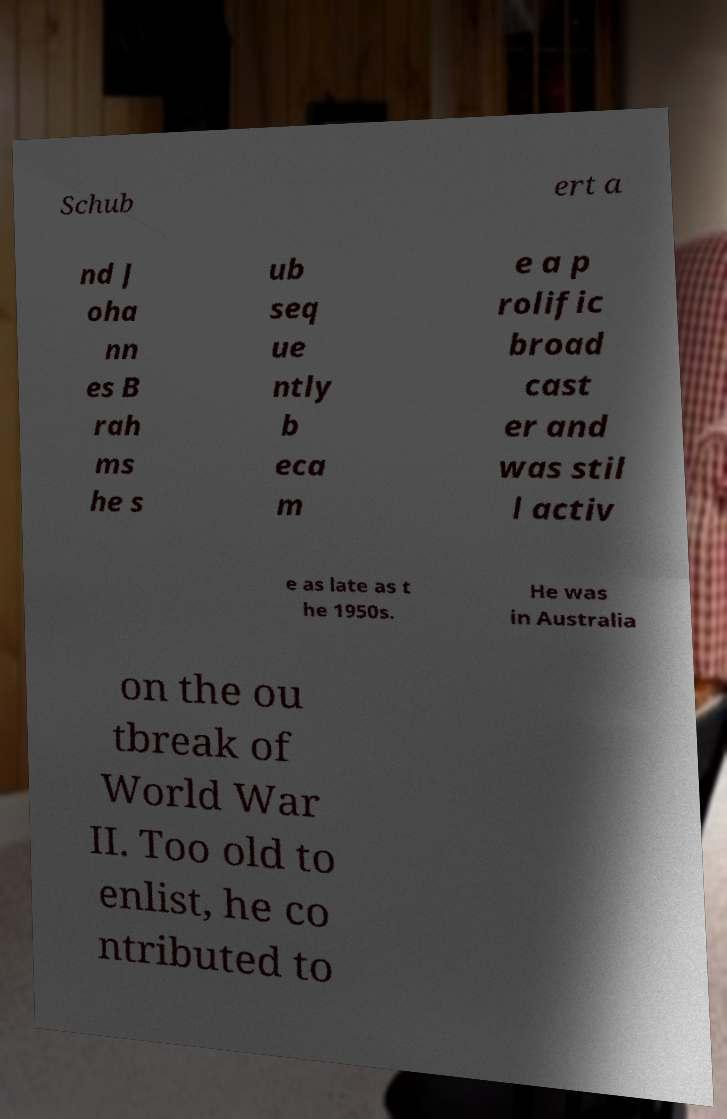Could you assist in decoding the text presented in this image and type it out clearly? Schub ert a nd J oha nn es B rah ms he s ub seq ue ntly b eca m e a p rolific broad cast er and was stil l activ e as late as t he 1950s. He was in Australia on the ou tbreak of World War II. Too old to enlist, he co ntributed to 